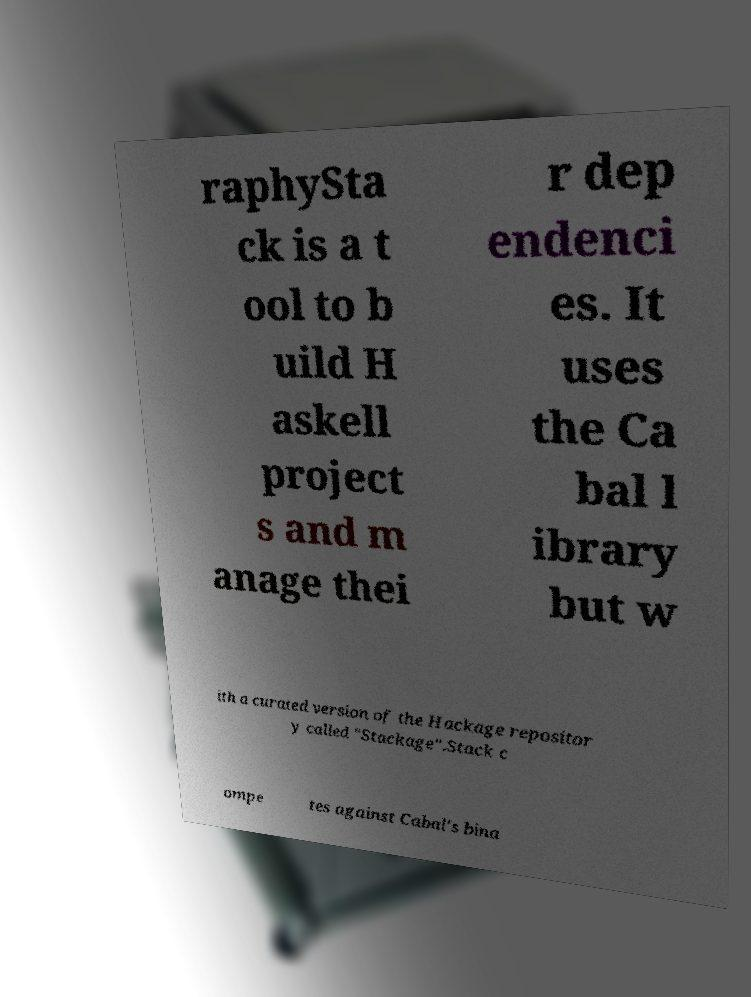Can you accurately transcribe the text from the provided image for me? raphySta ck is a t ool to b uild H askell project s and m anage thei r dep endenci es. It uses the Ca bal l ibrary but w ith a curated version of the Hackage repositor y called "Stackage".Stack c ompe tes against Cabal's bina 